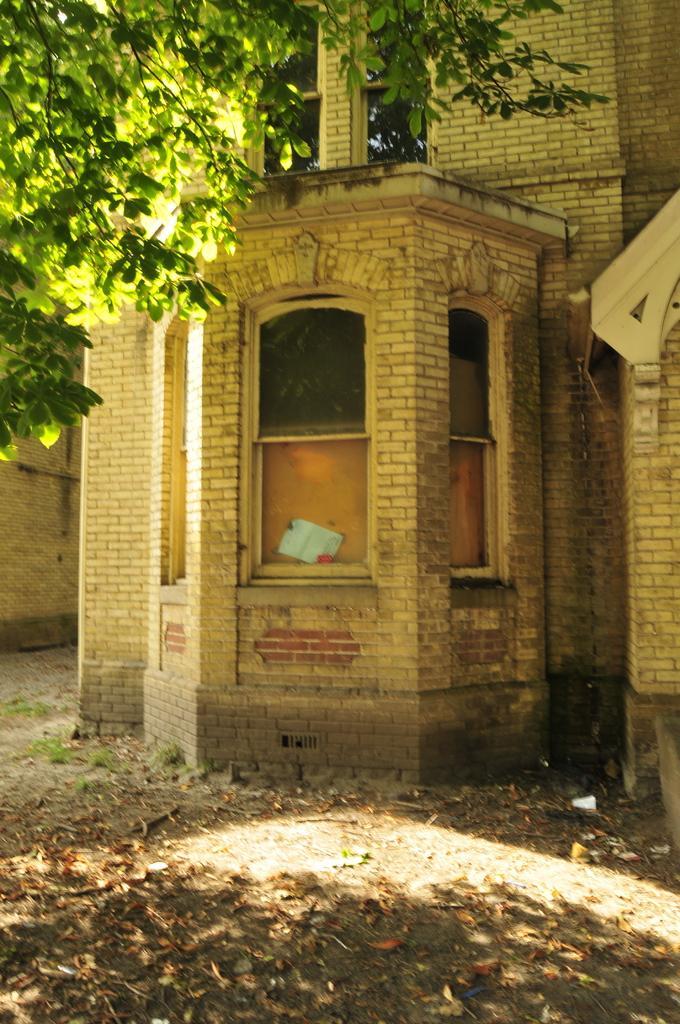Can you describe this image briefly? In this image we can see building, trees and shredded leaves on the ground. 